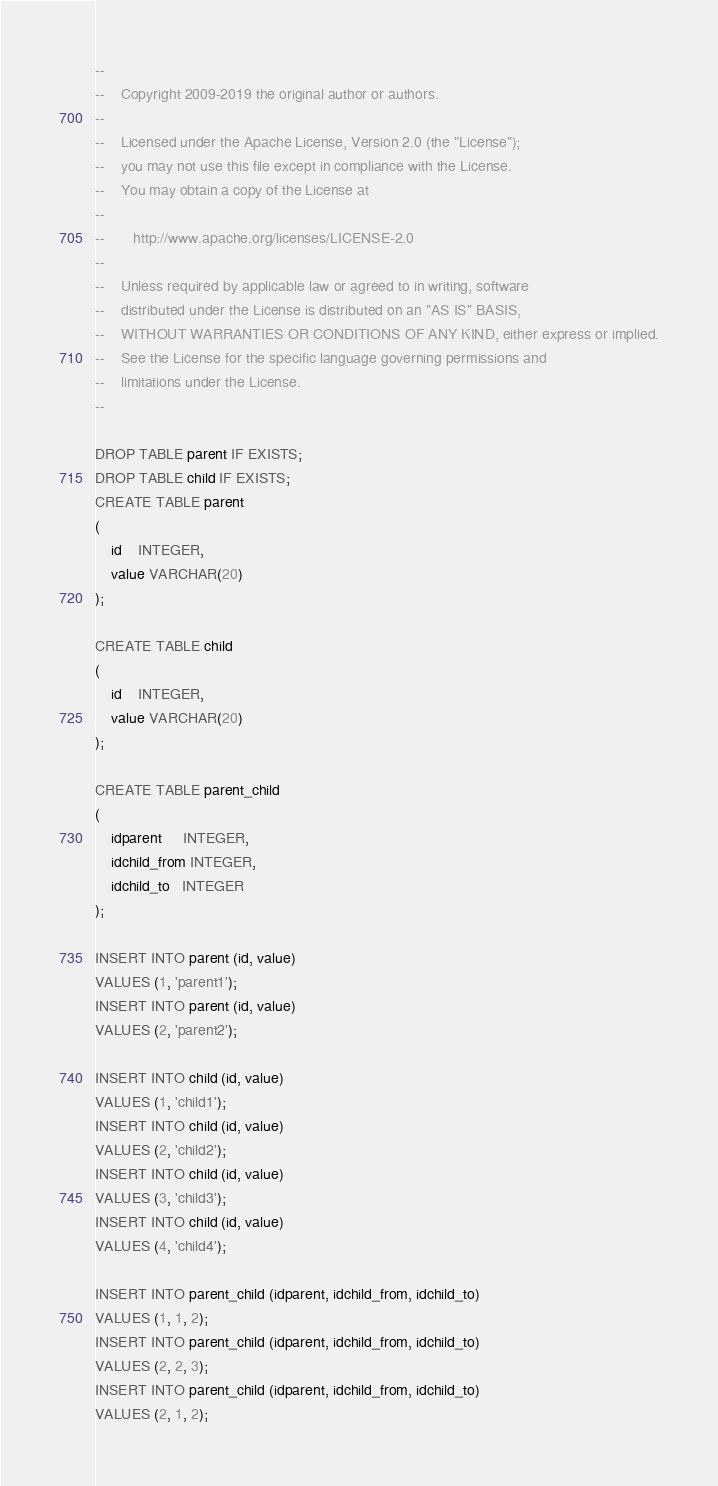<code> <loc_0><loc_0><loc_500><loc_500><_SQL_>--
--    Copyright 2009-2019 the original author or authors.
--
--    Licensed under the Apache License, Version 2.0 (the "License");
--    you may not use this file except in compliance with the License.
--    You may obtain a copy of the License at
--
--       http://www.apache.org/licenses/LICENSE-2.0
--
--    Unless required by applicable law or agreed to in writing, software
--    distributed under the License is distributed on an "AS IS" BASIS,
--    WITHOUT WARRANTIES OR CONDITIONS OF ANY KIND, either express or implied.
--    See the License for the specific language governing permissions and
--    limitations under the License.
--

DROP TABLE parent IF EXISTS;
DROP TABLE child IF EXISTS;
CREATE TABLE parent
(
    id    INTEGER,
    value VARCHAR(20)
);

CREATE TABLE child
(
    id    INTEGER,
    value VARCHAR(20)
);

CREATE TABLE parent_child
(
    idparent     INTEGER,
    idchild_from INTEGER,
    idchild_to   INTEGER
);

INSERT INTO parent (id, value)
VALUES (1, 'parent1');
INSERT INTO parent (id, value)
VALUES (2, 'parent2');

INSERT INTO child (id, value)
VALUES (1, 'child1');
INSERT INTO child (id, value)
VALUES (2, 'child2');
INSERT INTO child (id, value)
VALUES (3, 'child3');
INSERT INTO child (id, value)
VALUES (4, 'child4');

INSERT INTO parent_child (idparent, idchild_from, idchild_to)
VALUES (1, 1, 2);
INSERT INTO parent_child (idparent, idchild_from, idchild_to)
VALUES (2, 2, 3);
INSERT INTO parent_child (idparent, idchild_from, idchild_to)
VALUES (2, 1, 2);</code> 